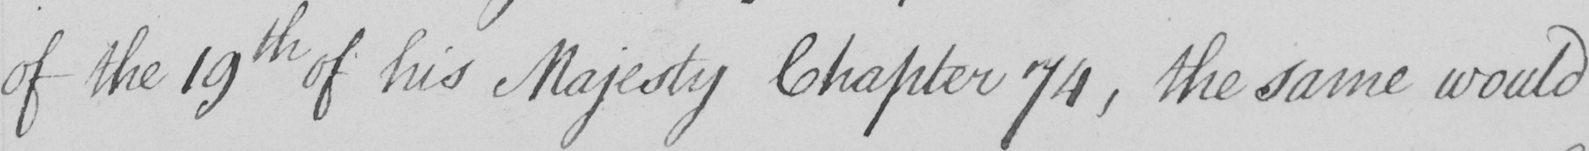Can you read and transcribe this handwriting? of the 19th of his Majesty Chapter 74 , the same would 